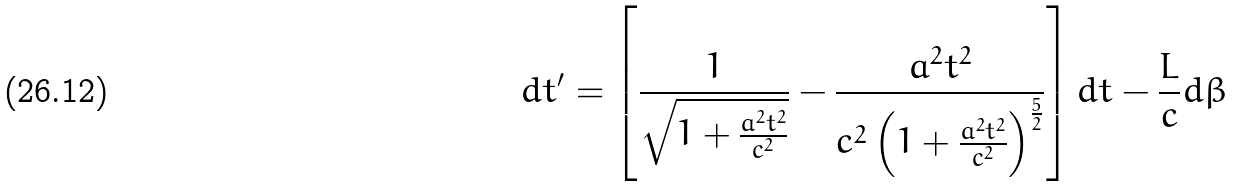Convert formula to latex. <formula><loc_0><loc_0><loc_500><loc_500>d t ^ { \prime } = \left [ \frac { 1 } { \sqrt { 1 + \frac { a ^ { 2 } t ^ { 2 } } { c ^ { 2 } } } } - \frac { a ^ { 2 } t ^ { 2 } } { c ^ { 2 } \left ( 1 + \frac { a ^ { 2 } t ^ { 2 } } { c ^ { 2 } } \right ) ^ { \frac { 5 } { 2 } } } \right ] d t - \frac { L } { c } d \beta</formula> 